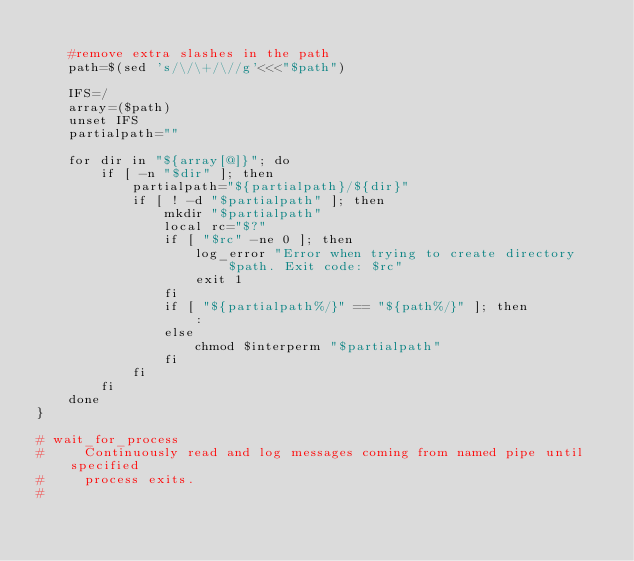<code> <loc_0><loc_0><loc_500><loc_500><_Bash_>    
    #remove extra slashes in the path
    path=$(sed 's/\/\+/\//g'<<<"$path")
    
    IFS=/
    array=($path)
    unset IFS
    partialpath=""

    for dir in "${array[@]}"; do
        if [ -n "$dir" ]; then
            partialpath="${partialpath}/${dir}"
            if [ ! -d "$partialpath" ]; then
                mkdir "$partialpath"
                local rc="$?"
                if [ "$rc" -ne 0 ]; then
                    log_error "Error when trying to create directory $path. Exit code: $rc"
                    exit 1
                fi
                if [ "${partialpath%/}" == "${path%/}" ]; then
                    :
                else
                    chmod $interperm "$partialpath"
                fi
            fi
        fi
    done
}

# wait_for_process
#     Continuously read and log messages coming from named pipe until specified
#     process exits.
# </code> 